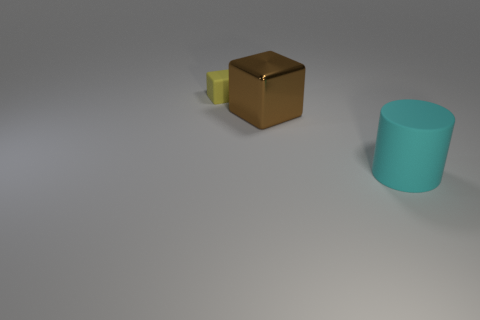Add 3 yellow blocks. How many objects exist? 6 Subtract all cubes. How many objects are left? 1 Add 2 large green shiny spheres. How many large green shiny spheres exist? 2 Subtract 0 green blocks. How many objects are left? 3 Subtract all tiny things. Subtract all big cubes. How many objects are left? 1 Add 1 cyan rubber objects. How many cyan rubber objects are left? 2 